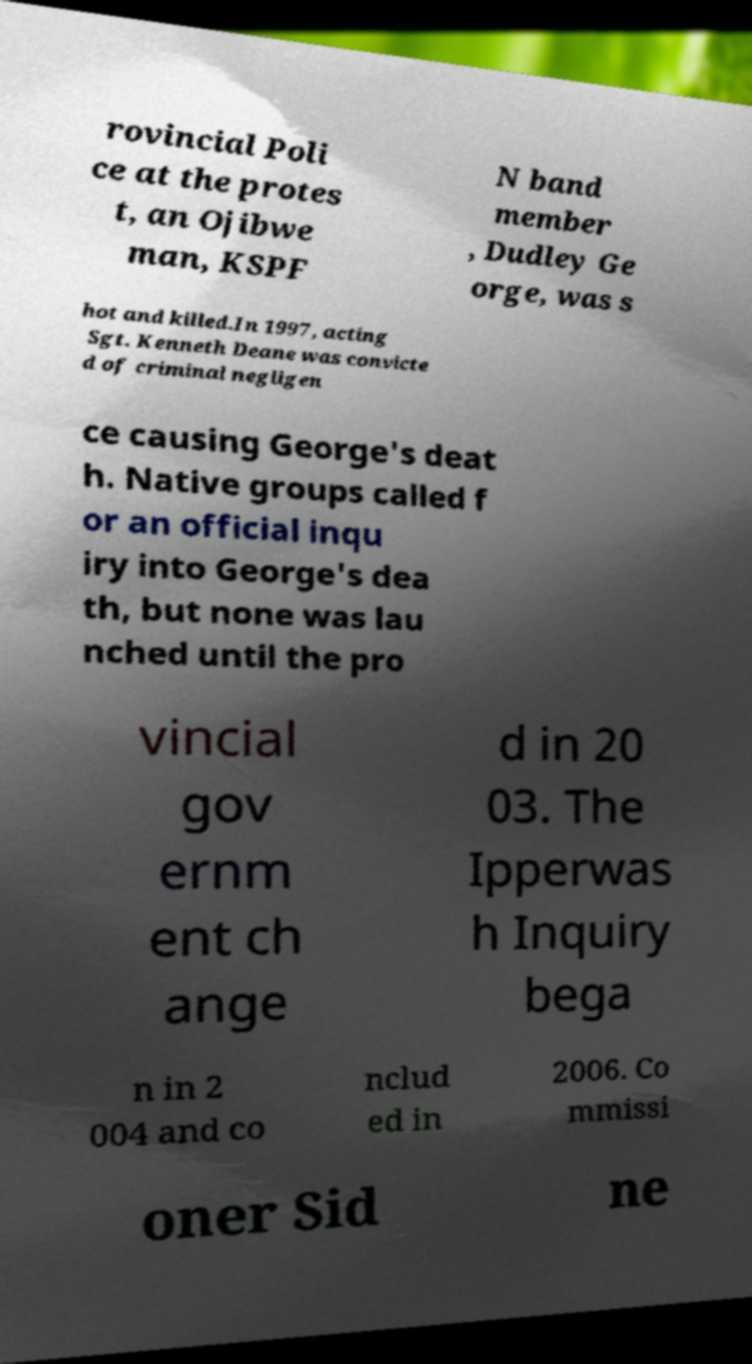Can you accurately transcribe the text from the provided image for me? rovincial Poli ce at the protes t, an Ojibwe man, KSPF N band member , Dudley Ge orge, was s hot and killed.In 1997, acting Sgt. Kenneth Deane was convicte d of criminal negligen ce causing George's deat h. Native groups called f or an official inqu iry into George's dea th, but none was lau nched until the pro vincial gov ernm ent ch ange d in 20 03. The Ipperwas h Inquiry bega n in 2 004 and co nclud ed in 2006. Co mmissi oner Sid ne 